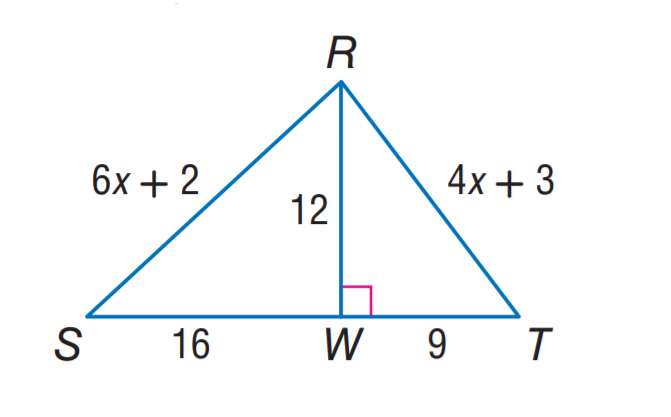Answer the mathemtical geometry problem and directly provide the correct option letter.
Question: Find R S.
Choices: A: 15 B: 16 C: 20 D: 25 C 